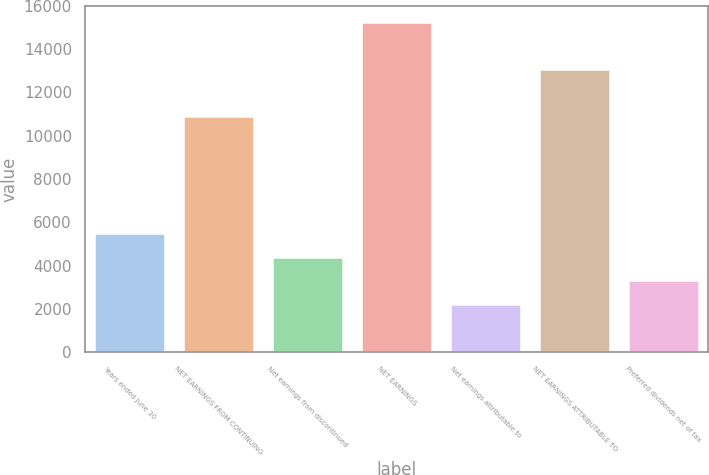<chart> <loc_0><loc_0><loc_500><loc_500><bar_chart><fcel>Years ended June 30<fcel>NET EARNINGS FROM CONTINUING<fcel>Net earnings from discontinued<fcel>NET EARNINGS<fcel>Net earnings attributable to<fcel>NET EARNINGS ATTRIBUTABLE TO<fcel>Preferred dividends net of tax<nl><fcel>5485<fcel>10904<fcel>4401.2<fcel>15239.2<fcel>2233.6<fcel>13071.6<fcel>3317.4<nl></chart> 